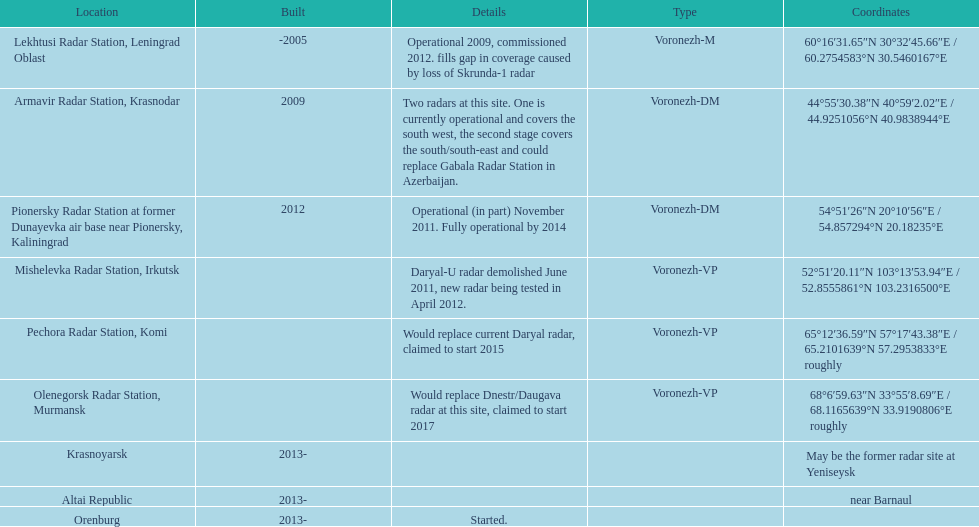What is the overall count of locations? 9. 